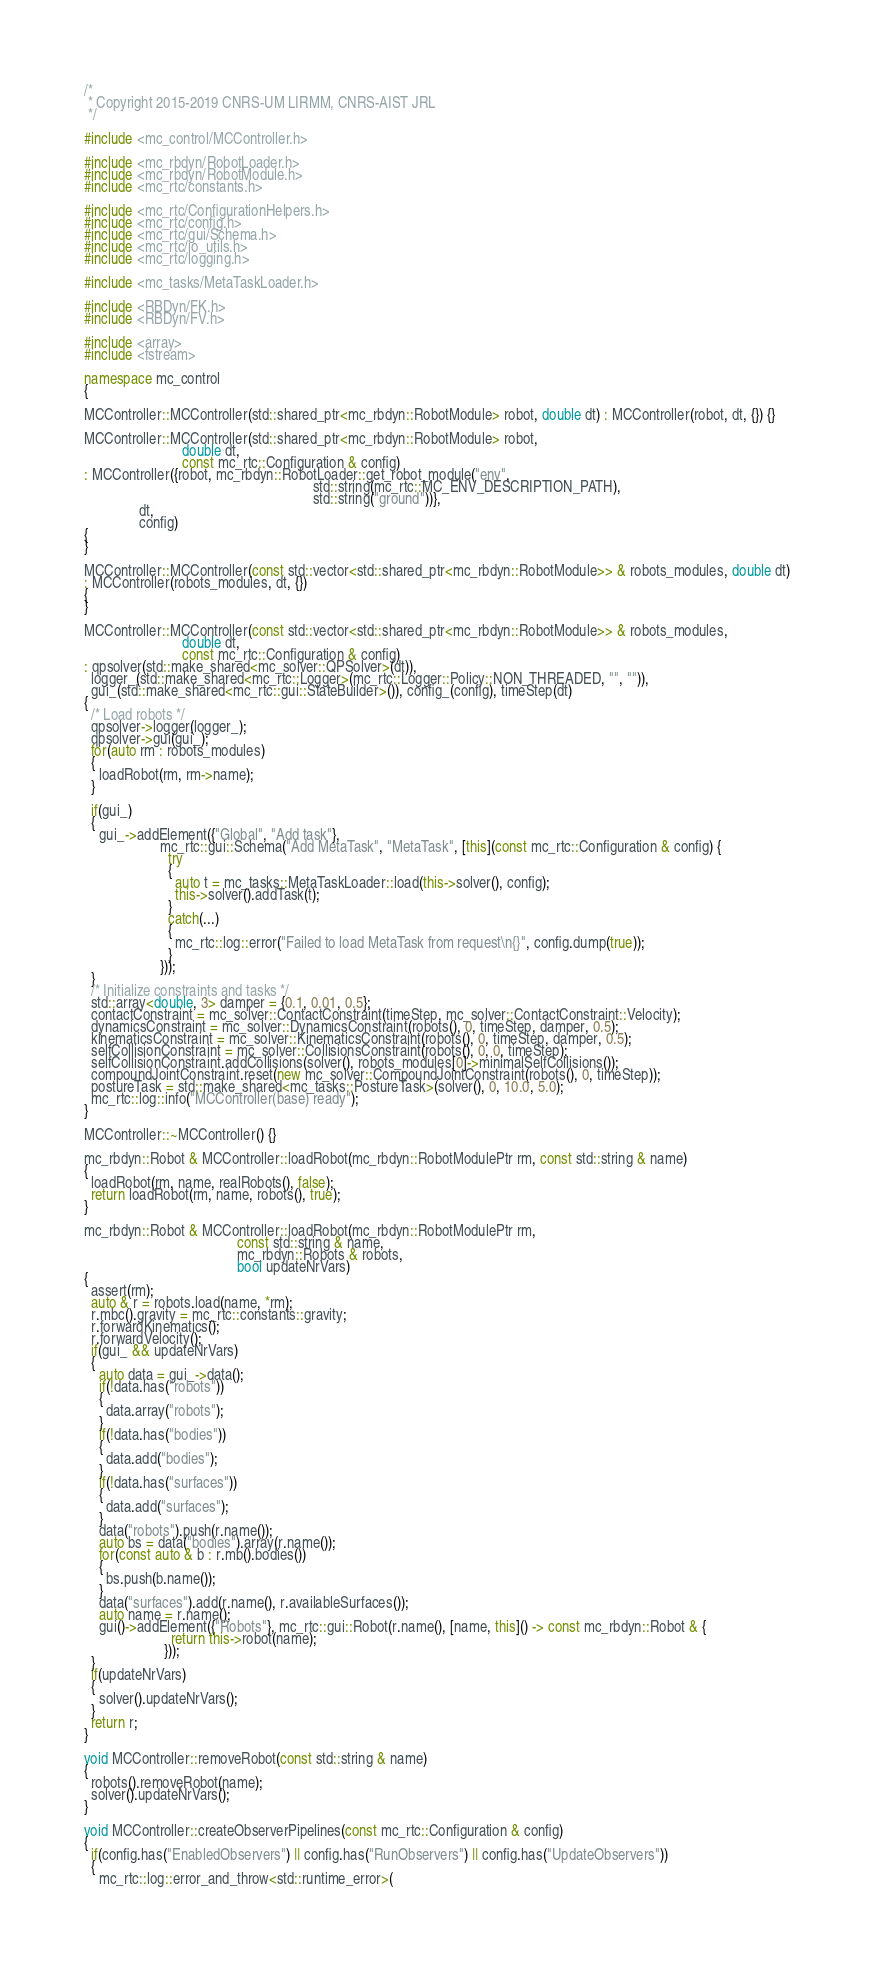Convert code to text. <code><loc_0><loc_0><loc_500><loc_500><_C++_>/*
 * Copyright 2015-2019 CNRS-UM LIRMM, CNRS-AIST JRL
 */

#include <mc_control/MCController.h>

#include <mc_rbdyn/RobotLoader.h>
#include <mc_rbdyn/RobotModule.h>
#include <mc_rtc/constants.h>

#include <mc_rtc/ConfigurationHelpers.h>
#include <mc_rtc/config.h>
#include <mc_rtc/gui/Schema.h>
#include <mc_rtc/io_utils.h>
#include <mc_rtc/logging.h>

#include <mc_tasks/MetaTaskLoader.h>

#include <RBDyn/FK.h>
#include <RBDyn/FV.h>

#include <array>
#include <fstream>

namespace mc_control
{

MCController::MCController(std::shared_ptr<mc_rbdyn::RobotModule> robot, double dt) : MCController(robot, dt, {}) {}

MCController::MCController(std::shared_ptr<mc_rbdyn::RobotModule> robot,
                           double dt,
                           const mc_rtc::Configuration & config)
: MCController({robot, mc_rbdyn::RobotLoader::get_robot_module("env",
                                                               std::string(mc_rtc::MC_ENV_DESCRIPTION_PATH),
                                                               std::string("ground"))},
               dt,
               config)
{
}

MCController::MCController(const std::vector<std::shared_ptr<mc_rbdyn::RobotModule>> & robots_modules, double dt)
: MCController(robots_modules, dt, {})
{
}

MCController::MCController(const std::vector<std::shared_ptr<mc_rbdyn::RobotModule>> & robots_modules,
                           double dt,
                           const mc_rtc::Configuration & config)
: qpsolver(std::make_shared<mc_solver::QPSolver>(dt)),
  logger_(std::make_shared<mc_rtc::Logger>(mc_rtc::Logger::Policy::NON_THREADED, "", "")),
  gui_(std::make_shared<mc_rtc::gui::StateBuilder>()), config_(config), timeStep(dt)
{
  /* Load robots */
  qpsolver->logger(logger_);
  qpsolver->gui(gui_);
  for(auto rm : robots_modules)
  {
    loadRobot(rm, rm->name);
  }

  if(gui_)
  {
    gui_->addElement({"Global", "Add task"},
                     mc_rtc::gui::Schema("Add MetaTask", "MetaTask", [this](const mc_rtc::Configuration & config) {
                       try
                       {
                         auto t = mc_tasks::MetaTaskLoader::load(this->solver(), config);
                         this->solver().addTask(t);
                       }
                       catch(...)
                       {
                         mc_rtc::log::error("Failed to load MetaTask from request\n{}", config.dump(true));
                       }
                     }));
  }
  /* Initialize constraints and tasks */
  std::array<double, 3> damper = {0.1, 0.01, 0.5};
  contactConstraint = mc_solver::ContactConstraint(timeStep, mc_solver::ContactConstraint::Velocity);
  dynamicsConstraint = mc_solver::DynamicsConstraint(robots(), 0, timeStep, damper, 0.5);
  kinematicsConstraint = mc_solver::KinematicsConstraint(robots(), 0, timeStep, damper, 0.5);
  selfCollisionConstraint = mc_solver::CollisionsConstraint(robots(), 0, 0, timeStep);
  selfCollisionConstraint.addCollisions(solver(), robots_modules[0]->minimalSelfCollisions());
  compoundJointConstraint.reset(new mc_solver::CompoundJointConstraint(robots(), 0, timeStep));
  postureTask = std::make_shared<mc_tasks::PostureTask>(solver(), 0, 10.0, 5.0);
  mc_rtc::log::info("MCController(base) ready");
}

MCController::~MCController() {}

mc_rbdyn::Robot & MCController::loadRobot(mc_rbdyn::RobotModulePtr rm, const std::string & name)
{
  loadRobot(rm, name, realRobots(), false);
  return loadRobot(rm, name, robots(), true);
}

mc_rbdyn::Robot & MCController::loadRobot(mc_rbdyn::RobotModulePtr rm,
                                          const std::string & name,
                                          mc_rbdyn::Robots & robots,
                                          bool updateNrVars)
{
  assert(rm);
  auto & r = robots.load(name, *rm);
  r.mbc().gravity = mc_rtc::constants::gravity;
  r.forwardKinematics();
  r.forwardVelocity();
  if(gui_ && updateNrVars)
  {
    auto data = gui_->data();
    if(!data.has("robots"))
    {
      data.array("robots");
    }
    if(!data.has("bodies"))
    {
      data.add("bodies");
    }
    if(!data.has("surfaces"))
    {
      data.add("surfaces");
    }
    data("robots").push(r.name());
    auto bs = data("bodies").array(r.name());
    for(const auto & b : r.mb().bodies())
    {
      bs.push(b.name());
    }
    data("surfaces").add(r.name(), r.availableSurfaces());
    auto name = r.name();
    gui()->addElement({"Robots"}, mc_rtc::gui::Robot(r.name(), [name, this]() -> const mc_rbdyn::Robot & {
                        return this->robot(name);
                      }));
  }
  if(updateNrVars)
  {
    solver().updateNrVars();
  }
  return r;
}

void MCController::removeRobot(const std::string & name)
{
  robots().removeRobot(name);
  solver().updateNrVars();
}

void MCController::createObserverPipelines(const mc_rtc::Configuration & config)
{
  if(config.has("EnabledObservers") || config.has("RunObservers") || config.has("UpdateObservers"))
  {
    mc_rtc::log::error_and_throw<std::runtime_error>(</code> 